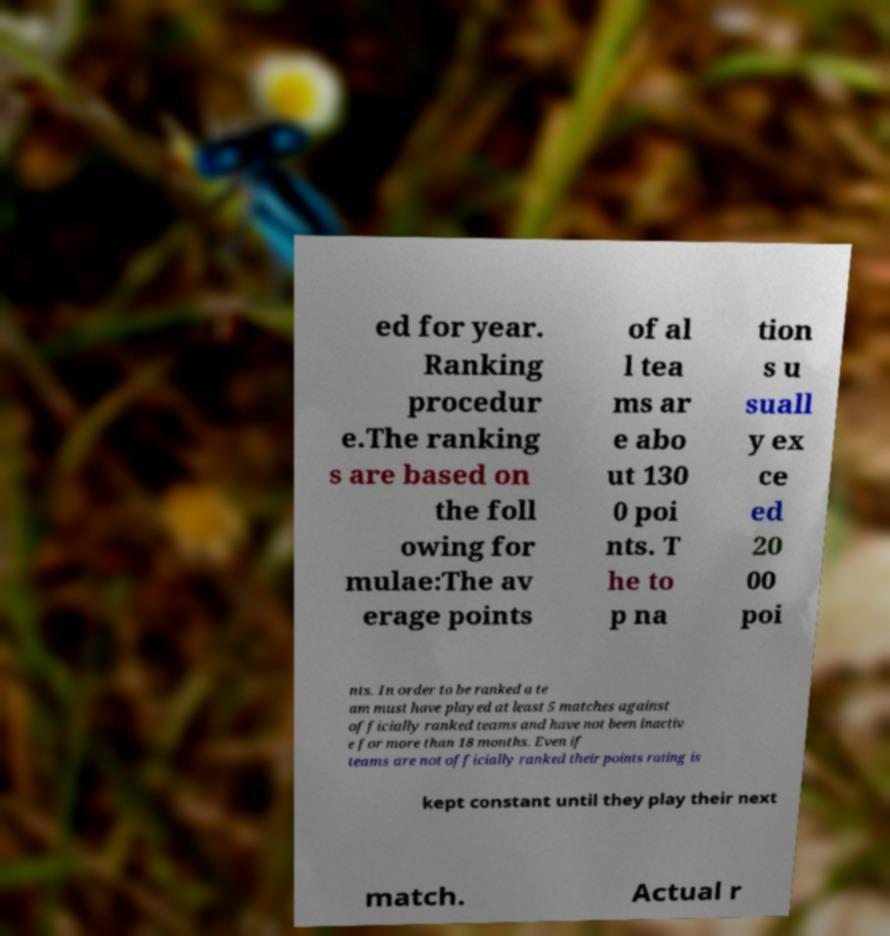Please identify and transcribe the text found in this image. ed for year. Ranking procedur e.The ranking s are based on the foll owing for mulae:The av erage points of al l tea ms ar e abo ut 130 0 poi nts. T he to p na tion s u suall y ex ce ed 20 00 poi nts. In order to be ranked a te am must have played at least 5 matches against officially ranked teams and have not been inactiv e for more than 18 months. Even if teams are not officially ranked their points rating is kept constant until they play their next match. Actual r 